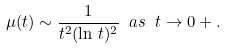Convert formula to latex. <formula><loc_0><loc_0><loc_500><loc_500>\mu ( t ) \sim \frac { 1 } { t ^ { 2 } ( \ln \, t ) ^ { 2 } } \ a s \ t \to 0 + .</formula> 